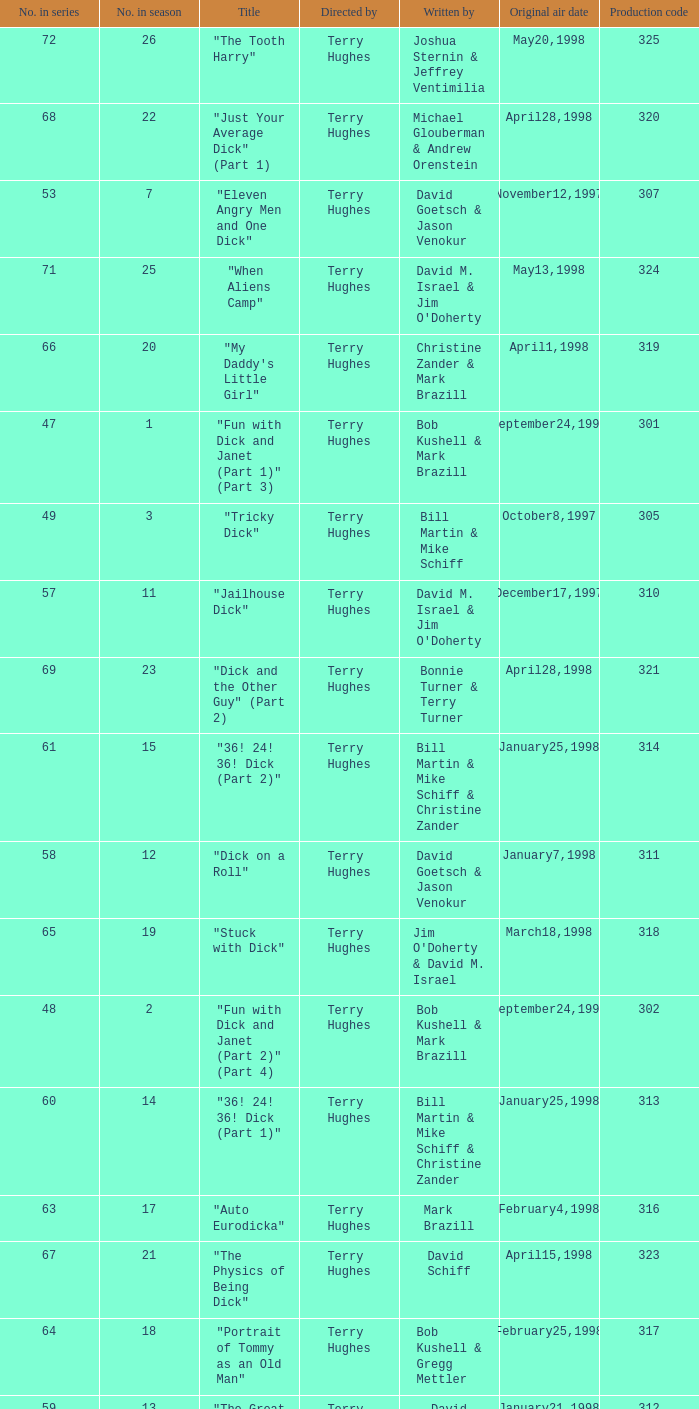Who were the writers of the episode titled "Tricky Dick"? Bill Martin & Mike Schiff. Can you give me this table as a dict? {'header': ['No. in series', 'No. in season', 'Title', 'Directed by', 'Written by', 'Original air date', 'Production code'], 'rows': [['72', '26', '"The Tooth Harry"', 'Terry Hughes', 'Joshua Sternin & Jeffrey Ventimilia', 'May20,1998', '325'], ['68', '22', '"Just Your Average Dick" (Part 1)', 'Terry Hughes', 'Michael Glouberman & Andrew Orenstein', 'April28,1998', '320'], ['53', '7', '"Eleven Angry Men and One Dick"', 'Terry Hughes', 'David Goetsch & Jason Venokur', 'November12,1997', '307'], ['71', '25', '"When Aliens Camp"', 'Terry Hughes', "David M. Israel & Jim O'Doherty", 'May13,1998', '324'], ['66', '20', '"My Daddy\'s Little Girl"', 'Terry Hughes', 'Christine Zander & Mark Brazill', 'April1,1998', '319'], ['47', '1', '"Fun with Dick and Janet (Part 1)" (Part 3)', 'Terry Hughes', 'Bob Kushell & Mark Brazill', 'September24,1997', '301'], ['49', '3', '"Tricky Dick"', 'Terry Hughes', 'Bill Martin & Mike Schiff', 'October8,1997', '305'], ['57', '11', '"Jailhouse Dick"', 'Terry Hughes', "David M. Israel & Jim O'Doherty", 'December17,1997', '310'], ['69', '23', '"Dick and the Other Guy" (Part 2)', 'Terry Hughes', 'Bonnie Turner & Terry Turner', 'April28,1998', '321'], ['61', '15', '"36! 24! 36! Dick (Part 2)"', 'Terry Hughes', 'Bill Martin & Mike Schiff & Christine Zander', 'January25,1998', '314'], ['58', '12', '"Dick on a Roll"', 'Terry Hughes', 'David Goetsch & Jason Venokur', 'January7,1998', '311'], ['65', '19', '"Stuck with Dick"', 'Terry Hughes', "Jim O'Doherty & David M. Israel", 'March18,1998', '318'], ['48', '2', '"Fun with Dick and Janet (Part 2)" (Part 4)', 'Terry Hughes', 'Bob Kushell & Mark Brazill', 'September24,1997', '302'], ['60', '14', '"36! 24! 36! Dick (Part 1)"', 'Terry Hughes', 'Bill Martin & Mike Schiff & Christine Zander', 'January25,1998', '313'], ['63', '17', '"Auto Eurodicka"', 'Terry Hughes', 'Mark Brazill', 'February4,1998', '316'], ['67', '21', '"The Physics of Being Dick"', 'Terry Hughes', 'David Schiff', 'April15,1998', '323'], ['64', '18', '"Portrait of Tommy as an Old Man"', 'Terry Hughes', 'Bob Kushell & Gregg Mettler', 'February25,1998', '317'], ['59', '13', '"The Great Dickdater"', 'Terry Hughes', 'David Sacks', 'January21,1998', '312'], ['62', '16', '"Pickles and Ice Cream"', 'Terry Hughes', 'Bob Kushell', 'January28,1998', '315'], ['56', '10', '"Tom, Dick and Mary"', 'Terry Hughes', 'Bonnie Turner & Terry Turner', 'December3,1997', '309'], ['52', '6', '"Moby Dick"', 'Terry Hughes', 'Michael Glouberman & Andrew Orenstein', 'November5,1997', '303'], ['51', '5', '"Scaredy Dick"', 'Terry Hughes', 'David Sacks', 'October29,1997', '306'], ['70', '24', '"Sally and Don\'s First Kiss"', 'Terry Hughes', 'David Sacks', 'May6,1998', '322'], ['55', '9', '"Seven Deadly Clips"', 'Terry Hughes', 'Michael Glouberman & Andrew Orenstein', 'December3,1997', '327'], ['54', '8', '"A Friend in Dick"', 'Terry Hughes', 'Gregg Mettler', 'November19,1997', '308'], ['50', '4', '"Dick-in-Law"', 'Terry Hughes', 'Christine Zander', 'October15,1997', '304']]} 